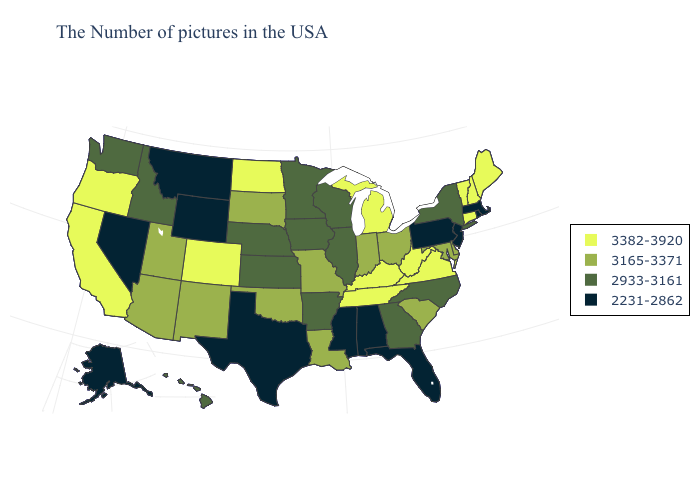Name the states that have a value in the range 2231-2862?
Answer briefly. Massachusetts, Rhode Island, New Jersey, Pennsylvania, Florida, Alabama, Mississippi, Texas, Wyoming, Montana, Nevada, Alaska. Name the states that have a value in the range 3165-3371?
Write a very short answer. Delaware, Maryland, South Carolina, Ohio, Indiana, Louisiana, Missouri, Oklahoma, South Dakota, New Mexico, Utah, Arizona. Does Maine have the lowest value in the Northeast?
Concise answer only. No. What is the highest value in the USA?
Write a very short answer. 3382-3920. Name the states that have a value in the range 3382-3920?
Write a very short answer. Maine, New Hampshire, Vermont, Connecticut, Virginia, West Virginia, Michigan, Kentucky, Tennessee, North Dakota, Colorado, California, Oregon. Does Hawaii have the same value as New Mexico?
Concise answer only. No. Does Virginia have a higher value than South Dakota?
Concise answer only. Yes. Name the states that have a value in the range 2231-2862?
Concise answer only. Massachusetts, Rhode Island, New Jersey, Pennsylvania, Florida, Alabama, Mississippi, Texas, Wyoming, Montana, Nevada, Alaska. Does Nebraska have the same value as North Carolina?
Keep it brief. Yes. Name the states that have a value in the range 2933-3161?
Quick response, please. New York, North Carolina, Georgia, Wisconsin, Illinois, Arkansas, Minnesota, Iowa, Kansas, Nebraska, Idaho, Washington, Hawaii. Which states have the lowest value in the West?
Quick response, please. Wyoming, Montana, Nevada, Alaska. Does Utah have the lowest value in the West?
Short answer required. No. What is the value of New Hampshire?
Short answer required. 3382-3920. What is the lowest value in the West?
Keep it brief. 2231-2862. What is the value of Delaware?
Concise answer only. 3165-3371. 